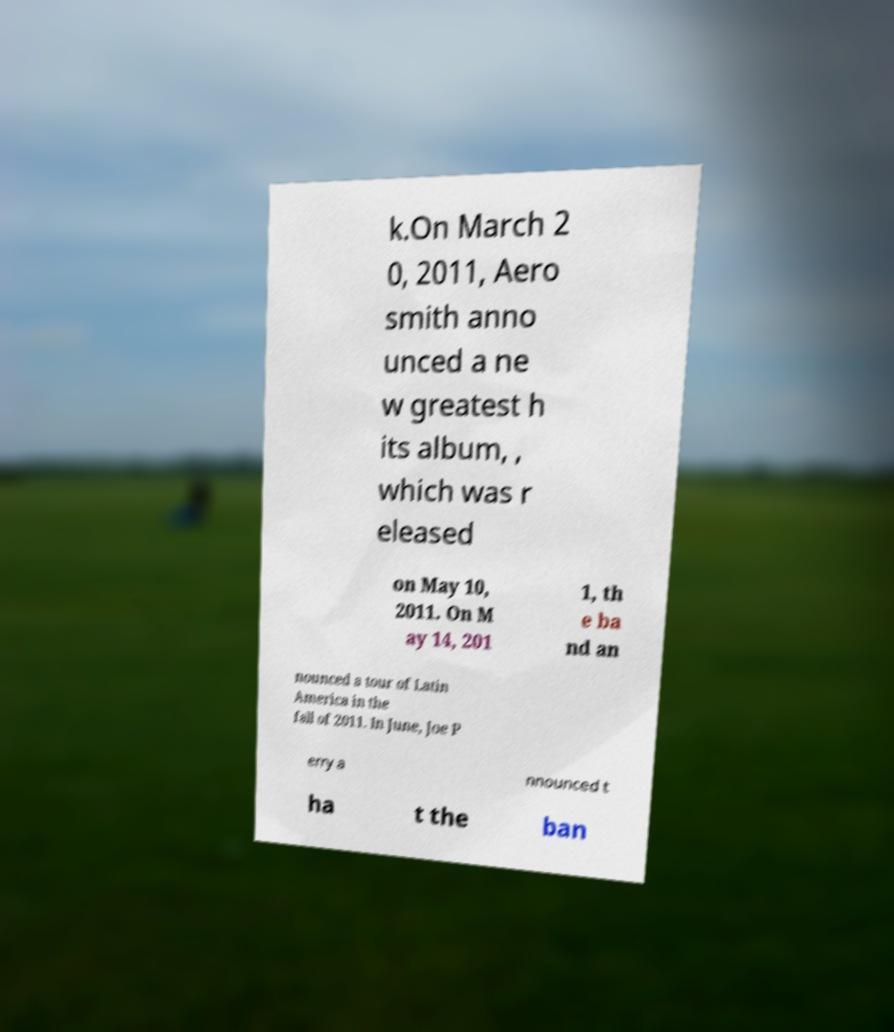For documentation purposes, I need the text within this image transcribed. Could you provide that? k.On March 2 0, 2011, Aero smith anno unced a ne w greatest h its album, , which was r eleased on May 10, 2011. On M ay 14, 201 1, th e ba nd an nounced a tour of Latin America in the fall of 2011. In June, Joe P erry a nnounced t ha t the ban 